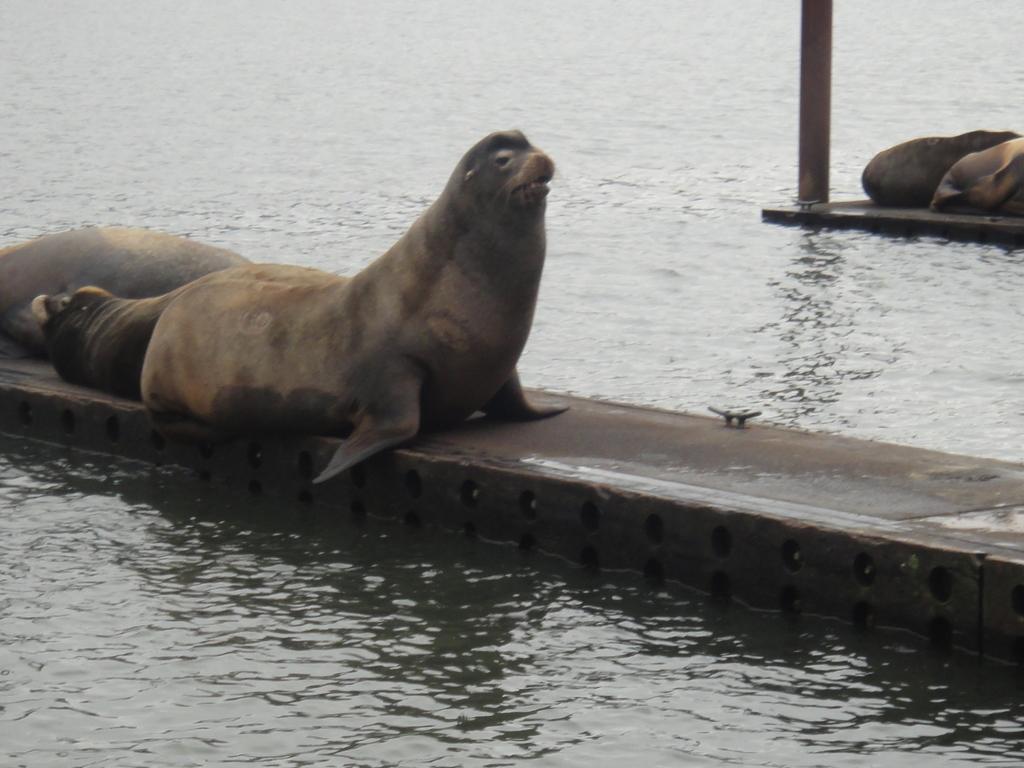Could you give a brief overview of what you see in this image? In this image I can see four seals on a fence, pole and water. This image is taken may be in the ocean. 